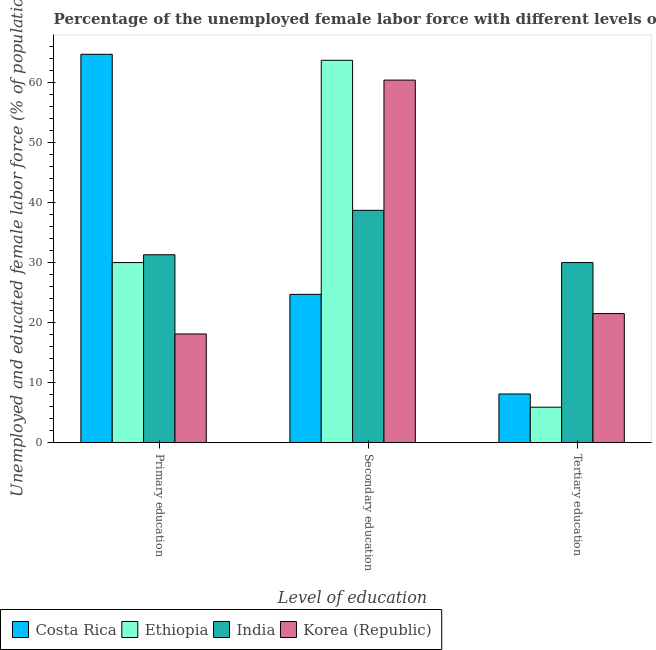How many different coloured bars are there?
Your answer should be very brief. 4. How many bars are there on the 3rd tick from the left?
Make the answer very short. 4. What is the percentage of female labor force who received secondary education in Korea (Republic)?
Ensure brevity in your answer.  60.4. Across all countries, what is the maximum percentage of female labor force who received primary education?
Your answer should be compact. 64.7. Across all countries, what is the minimum percentage of female labor force who received secondary education?
Your response must be concise. 24.7. In which country was the percentage of female labor force who received secondary education maximum?
Your response must be concise. Ethiopia. What is the total percentage of female labor force who received tertiary education in the graph?
Your answer should be compact. 65.5. What is the difference between the percentage of female labor force who received secondary education in Korea (Republic) and that in Costa Rica?
Keep it short and to the point. 35.7. What is the difference between the percentage of female labor force who received tertiary education in Costa Rica and the percentage of female labor force who received primary education in India?
Offer a very short reply. -23.2. What is the average percentage of female labor force who received primary education per country?
Offer a very short reply. 36.02. What is the difference between the percentage of female labor force who received primary education and percentage of female labor force who received secondary education in India?
Your answer should be very brief. -7.4. What is the ratio of the percentage of female labor force who received secondary education in Ethiopia to that in Costa Rica?
Provide a short and direct response. 2.58. Is the percentage of female labor force who received tertiary education in Ethiopia less than that in India?
Your response must be concise. Yes. Is the difference between the percentage of female labor force who received secondary education in Costa Rica and India greater than the difference between the percentage of female labor force who received primary education in Costa Rica and India?
Your answer should be very brief. No. What is the difference between the highest and the second highest percentage of female labor force who received primary education?
Your answer should be compact. 33.4. What is the difference between the highest and the lowest percentage of female labor force who received primary education?
Provide a succinct answer. 46.6. In how many countries, is the percentage of female labor force who received tertiary education greater than the average percentage of female labor force who received tertiary education taken over all countries?
Offer a very short reply. 2. Is the sum of the percentage of female labor force who received secondary education in India and Costa Rica greater than the maximum percentage of female labor force who received primary education across all countries?
Your response must be concise. No. What does the 1st bar from the left in Tertiary education represents?
Provide a succinct answer. Costa Rica. Is it the case that in every country, the sum of the percentage of female labor force who received primary education and percentage of female labor force who received secondary education is greater than the percentage of female labor force who received tertiary education?
Your answer should be compact. Yes. How many bars are there?
Keep it short and to the point. 12. What is the difference between two consecutive major ticks on the Y-axis?
Provide a succinct answer. 10. Are the values on the major ticks of Y-axis written in scientific E-notation?
Ensure brevity in your answer.  No. Does the graph contain grids?
Your answer should be very brief. No. Where does the legend appear in the graph?
Your response must be concise. Bottom left. How many legend labels are there?
Make the answer very short. 4. How are the legend labels stacked?
Provide a succinct answer. Horizontal. What is the title of the graph?
Ensure brevity in your answer.  Percentage of the unemployed female labor force with different levels of education in countries. Does "French Polynesia" appear as one of the legend labels in the graph?
Give a very brief answer. No. What is the label or title of the X-axis?
Your answer should be compact. Level of education. What is the label or title of the Y-axis?
Offer a very short reply. Unemployed and educated female labor force (% of population). What is the Unemployed and educated female labor force (% of population) in Costa Rica in Primary education?
Make the answer very short. 64.7. What is the Unemployed and educated female labor force (% of population) in India in Primary education?
Your response must be concise. 31.3. What is the Unemployed and educated female labor force (% of population) in Korea (Republic) in Primary education?
Your response must be concise. 18.1. What is the Unemployed and educated female labor force (% of population) of Costa Rica in Secondary education?
Make the answer very short. 24.7. What is the Unemployed and educated female labor force (% of population) of Ethiopia in Secondary education?
Provide a short and direct response. 63.7. What is the Unemployed and educated female labor force (% of population) of India in Secondary education?
Give a very brief answer. 38.7. What is the Unemployed and educated female labor force (% of population) of Korea (Republic) in Secondary education?
Provide a short and direct response. 60.4. What is the Unemployed and educated female labor force (% of population) in Costa Rica in Tertiary education?
Make the answer very short. 8.1. What is the Unemployed and educated female labor force (% of population) in Ethiopia in Tertiary education?
Ensure brevity in your answer.  5.9. What is the Unemployed and educated female labor force (% of population) in Korea (Republic) in Tertiary education?
Your answer should be very brief. 21.5. Across all Level of education, what is the maximum Unemployed and educated female labor force (% of population) in Costa Rica?
Provide a short and direct response. 64.7. Across all Level of education, what is the maximum Unemployed and educated female labor force (% of population) of Ethiopia?
Provide a short and direct response. 63.7. Across all Level of education, what is the maximum Unemployed and educated female labor force (% of population) of India?
Ensure brevity in your answer.  38.7. Across all Level of education, what is the maximum Unemployed and educated female labor force (% of population) of Korea (Republic)?
Give a very brief answer. 60.4. Across all Level of education, what is the minimum Unemployed and educated female labor force (% of population) of Costa Rica?
Provide a succinct answer. 8.1. Across all Level of education, what is the minimum Unemployed and educated female labor force (% of population) of Ethiopia?
Ensure brevity in your answer.  5.9. Across all Level of education, what is the minimum Unemployed and educated female labor force (% of population) of India?
Your answer should be compact. 30. Across all Level of education, what is the minimum Unemployed and educated female labor force (% of population) of Korea (Republic)?
Offer a terse response. 18.1. What is the total Unemployed and educated female labor force (% of population) of Costa Rica in the graph?
Give a very brief answer. 97.5. What is the total Unemployed and educated female labor force (% of population) in Ethiopia in the graph?
Your response must be concise. 99.6. What is the total Unemployed and educated female labor force (% of population) in India in the graph?
Keep it short and to the point. 100. What is the difference between the Unemployed and educated female labor force (% of population) in Ethiopia in Primary education and that in Secondary education?
Keep it short and to the point. -33.7. What is the difference between the Unemployed and educated female labor force (% of population) of Korea (Republic) in Primary education and that in Secondary education?
Your answer should be very brief. -42.3. What is the difference between the Unemployed and educated female labor force (% of population) in Costa Rica in Primary education and that in Tertiary education?
Provide a succinct answer. 56.6. What is the difference between the Unemployed and educated female labor force (% of population) in Ethiopia in Primary education and that in Tertiary education?
Ensure brevity in your answer.  24.1. What is the difference between the Unemployed and educated female labor force (% of population) of Korea (Republic) in Primary education and that in Tertiary education?
Make the answer very short. -3.4. What is the difference between the Unemployed and educated female labor force (% of population) of Ethiopia in Secondary education and that in Tertiary education?
Make the answer very short. 57.8. What is the difference between the Unemployed and educated female labor force (% of population) of Korea (Republic) in Secondary education and that in Tertiary education?
Your response must be concise. 38.9. What is the difference between the Unemployed and educated female labor force (% of population) in Costa Rica in Primary education and the Unemployed and educated female labor force (% of population) in Ethiopia in Secondary education?
Provide a succinct answer. 1. What is the difference between the Unemployed and educated female labor force (% of population) in Costa Rica in Primary education and the Unemployed and educated female labor force (% of population) in India in Secondary education?
Offer a very short reply. 26. What is the difference between the Unemployed and educated female labor force (% of population) of Ethiopia in Primary education and the Unemployed and educated female labor force (% of population) of India in Secondary education?
Your answer should be very brief. -8.7. What is the difference between the Unemployed and educated female labor force (% of population) of Ethiopia in Primary education and the Unemployed and educated female labor force (% of population) of Korea (Republic) in Secondary education?
Keep it short and to the point. -30.4. What is the difference between the Unemployed and educated female labor force (% of population) of India in Primary education and the Unemployed and educated female labor force (% of population) of Korea (Republic) in Secondary education?
Keep it short and to the point. -29.1. What is the difference between the Unemployed and educated female labor force (% of population) of Costa Rica in Primary education and the Unemployed and educated female labor force (% of population) of Ethiopia in Tertiary education?
Your answer should be compact. 58.8. What is the difference between the Unemployed and educated female labor force (% of population) in Costa Rica in Primary education and the Unemployed and educated female labor force (% of population) in India in Tertiary education?
Your answer should be compact. 34.7. What is the difference between the Unemployed and educated female labor force (% of population) of Costa Rica in Primary education and the Unemployed and educated female labor force (% of population) of Korea (Republic) in Tertiary education?
Keep it short and to the point. 43.2. What is the difference between the Unemployed and educated female labor force (% of population) of Ethiopia in Primary education and the Unemployed and educated female labor force (% of population) of Korea (Republic) in Tertiary education?
Make the answer very short. 8.5. What is the difference between the Unemployed and educated female labor force (% of population) in Costa Rica in Secondary education and the Unemployed and educated female labor force (% of population) in India in Tertiary education?
Your answer should be compact. -5.3. What is the difference between the Unemployed and educated female labor force (% of population) in Ethiopia in Secondary education and the Unemployed and educated female labor force (% of population) in India in Tertiary education?
Give a very brief answer. 33.7. What is the difference between the Unemployed and educated female labor force (% of population) of Ethiopia in Secondary education and the Unemployed and educated female labor force (% of population) of Korea (Republic) in Tertiary education?
Keep it short and to the point. 42.2. What is the average Unemployed and educated female labor force (% of population) in Costa Rica per Level of education?
Give a very brief answer. 32.5. What is the average Unemployed and educated female labor force (% of population) in Ethiopia per Level of education?
Keep it short and to the point. 33.2. What is the average Unemployed and educated female labor force (% of population) of India per Level of education?
Make the answer very short. 33.33. What is the average Unemployed and educated female labor force (% of population) of Korea (Republic) per Level of education?
Make the answer very short. 33.33. What is the difference between the Unemployed and educated female labor force (% of population) in Costa Rica and Unemployed and educated female labor force (% of population) in Ethiopia in Primary education?
Keep it short and to the point. 34.7. What is the difference between the Unemployed and educated female labor force (% of population) of Costa Rica and Unemployed and educated female labor force (% of population) of India in Primary education?
Give a very brief answer. 33.4. What is the difference between the Unemployed and educated female labor force (% of population) of Costa Rica and Unemployed and educated female labor force (% of population) of Korea (Republic) in Primary education?
Make the answer very short. 46.6. What is the difference between the Unemployed and educated female labor force (% of population) of India and Unemployed and educated female labor force (% of population) of Korea (Republic) in Primary education?
Your answer should be very brief. 13.2. What is the difference between the Unemployed and educated female labor force (% of population) of Costa Rica and Unemployed and educated female labor force (% of population) of Ethiopia in Secondary education?
Your answer should be very brief. -39. What is the difference between the Unemployed and educated female labor force (% of population) in Costa Rica and Unemployed and educated female labor force (% of population) in Korea (Republic) in Secondary education?
Provide a succinct answer. -35.7. What is the difference between the Unemployed and educated female labor force (% of population) of Ethiopia and Unemployed and educated female labor force (% of population) of India in Secondary education?
Your response must be concise. 25. What is the difference between the Unemployed and educated female labor force (% of population) of Ethiopia and Unemployed and educated female labor force (% of population) of Korea (Republic) in Secondary education?
Offer a very short reply. 3.3. What is the difference between the Unemployed and educated female labor force (% of population) of India and Unemployed and educated female labor force (% of population) of Korea (Republic) in Secondary education?
Provide a short and direct response. -21.7. What is the difference between the Unemployed and educated female labor force (% of population) of Costa Rica and Unemployed and educated female labor force (% of population) of India in Tertiary education?
Offer a terse response. -21.9. What is the difference between the Unemployed and educated female labor force (% of population) in Costa Rica and Unemployed and educated female labor force (% of population) in Korea (Republic) in Tertiary education?
Keep it short and to the point. -13.4. What is the difference between the Unemployed and educated female labor force (% of population) of Ethiopia and Unemployed and educated female labor force (% of population) of India in Tertiary education?
Ensure brevity in your answer.  -24.1. What is the difference between the Unemployed and educated female labor force (% of population) in Ethiopia and Unemployed and educated female labor force (% of population) in Korea (Republic) in Tertiary education?
Your answer should be very brief. -15.6. What is the ratio of the Unemployed and educated female labor force (% of population) in Costa Rica in Primary education to that in Secondary education?
Offer a very short reply. 2.62. What is the ratio of the Unemployed and educated female labor force (% of population) of Ethiopia in Primary education to that in Secondary education?
Provide a short and direct response. 0.47. What is the ratio of the Unemployed and educated female labor force (% of population) of India in Primary education to that in Secondary education?
Make the answer very short. 0.81. What is the ratio of the Unemployed and educated female labor force (% of population) of Korea (Republic) in Primary education to that in Secondary education?
Keep it short and to the point. 0.3. What is the ratio of the Unemployed and educated female labor force (% of population) of Costa Rica in Primary education to that in Tertiary education?
Provide a short and direct response. 7.99. What is the ratio of the Unemployed and educated female labor force (% of population) of Ethiopia in Primary education to that in Tertiary education?
Provide a succinct answer. 5.08. What is the ratio of the Unemployed and educated female labor force (% of population) of India in Primary education to that in Tertiary education?
Keep it short and to the point. 1.04. What is the ratio of the Unemployed and educated female labor force (% of population) in Korea (Republic) in Primary education to that in Tertiary education?
Offer a terse response. 0.84. What is the ratio of the Unemployed and educated female labor force (% of population) of Costa Rica in Secondary education to that in Tertiary education?
Your response must be concise. 3.05. What is the ratio of the Unemployed and educated female labor force (% of population) of Ethiopia in Secondary education to that in Tertiary education?
Provide a short and direct response. 10.8. What is the ratio of the Unemployed and educated female labor force (% of population) of India in Secondary education to that in Tertiary education?
Provide a short and direct response. 1.29. What is the ratio of the Unemployed and educated female labor force (% of population) in Korea (Republic) in Secondary education to that in Tertiary education?
Your answer should be very brief. 2.81. What is the difference between the highest and the second highest Unemployed and educated female labor force (% of population) of Ethiopia?
Provide a short and direct response. 33.7. What is the difference between the highest and the second highest Unemployed and educated female labor force (% of population) in Korea (Republic)?
Ensure brevity in your answer.  38.9. What is the difference between the highest and the lowest Unemployed and educated female labor force (% of population) in Costa Rica?
Ensure brevity in your answer.  56.6. What is the difference between the highest and the lowest Unemployed and educated female labor force (% of population) of Ethiopia?
Offer a very short reply. 57.8. What is the difference between the highest and the lowest Unemployed and educated female labor force (% of population) of India?
Offer a very short reply. 8.7. What is the difference between the highest and the lowest Unemployed and educated female labor force (% of population) in Korea (Republic)?
Make the answer very short. 42.3. 